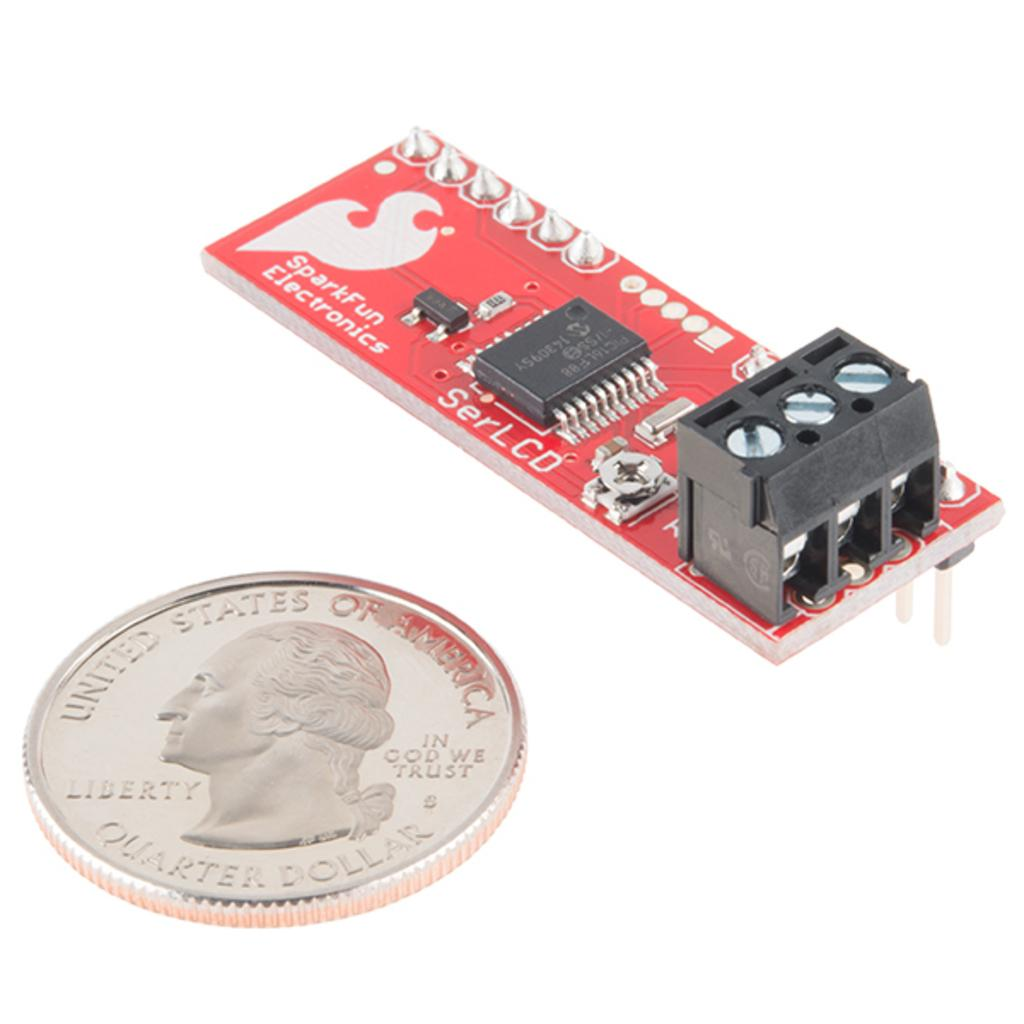Provide a one-sentence caption for the provided image. A electronic device being compared to the size of a quarter. 